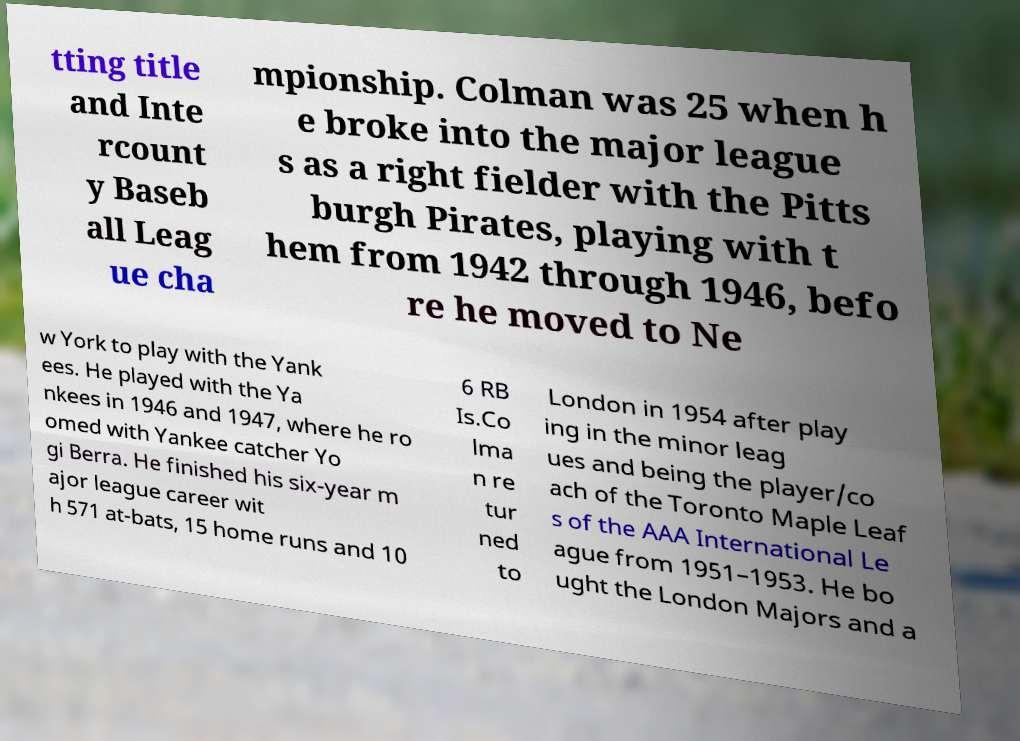Please identify and transcribe the text found in this image. tting title and Inte rcount y Baseb all Leag ue cha mpionship. Colman was 25 when h e broke into the major league s as a right fielder with the Pitts burgh Pirates, playing with t hem from 1942 through 1946, befo re he moved to Ne w York to play with the Yank ees. He played with the Ya nkees in 1946 and 1947, where he ro omed with Yankee catcher Yo gi Berra. He finished his six-year m ajor league career wit h 571 at-bats, 15 home runs and 10 6 RB Is.Co lma n re tur ned to London in 1954 after play ing in the minor leag ues and being the player/co ach of the Toronto Maple Leaf s of the AAA International Le ague from 1951–1953. He bo ught the London Majors and a 